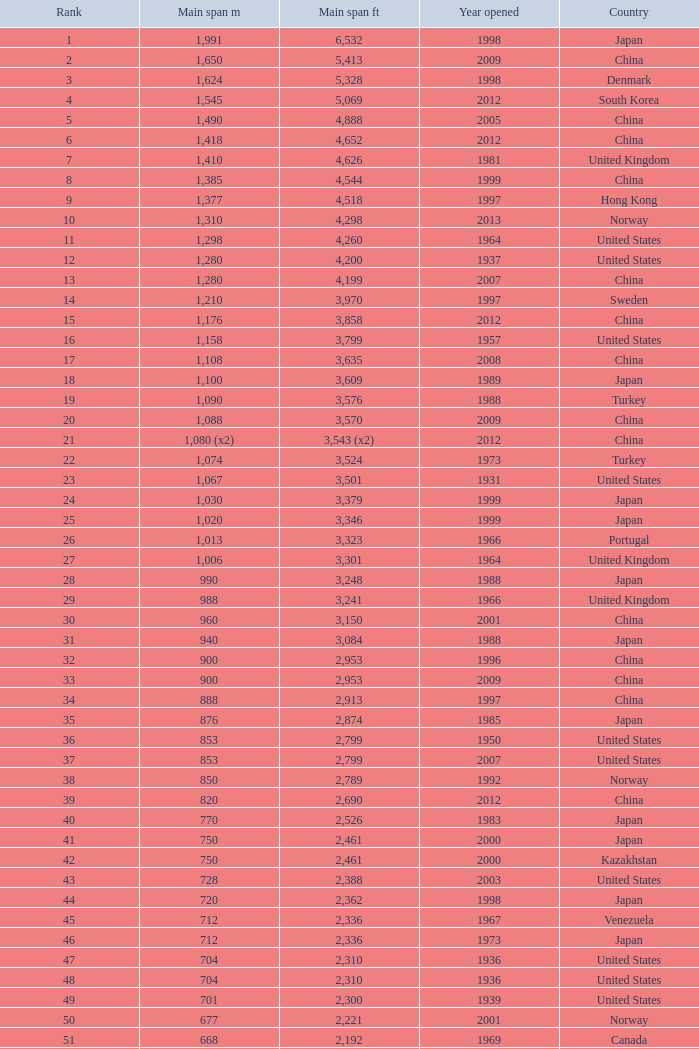What is the main span in feet from a year of 2009 or more recent with a rank less than 94 and 1,310 main span metres? 4298.0. 